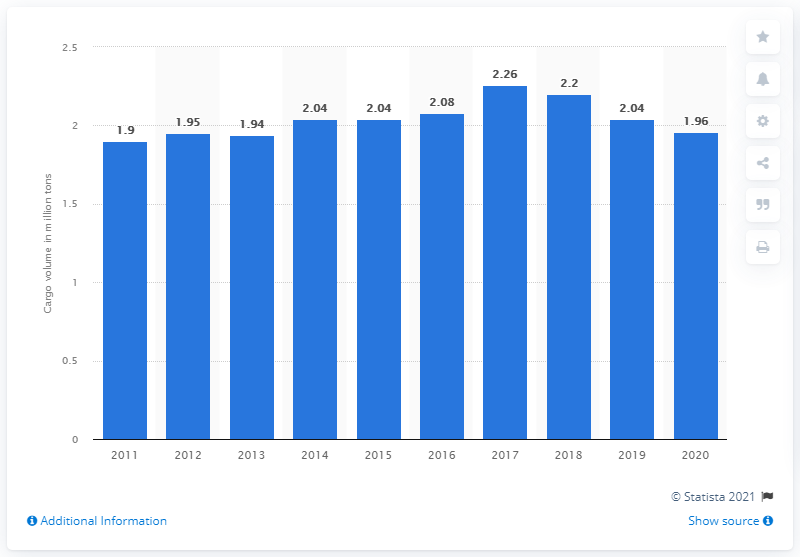Specify some key components in this picture. Narita International Airport's previous freight volume was 2,040,000 metric tons. 